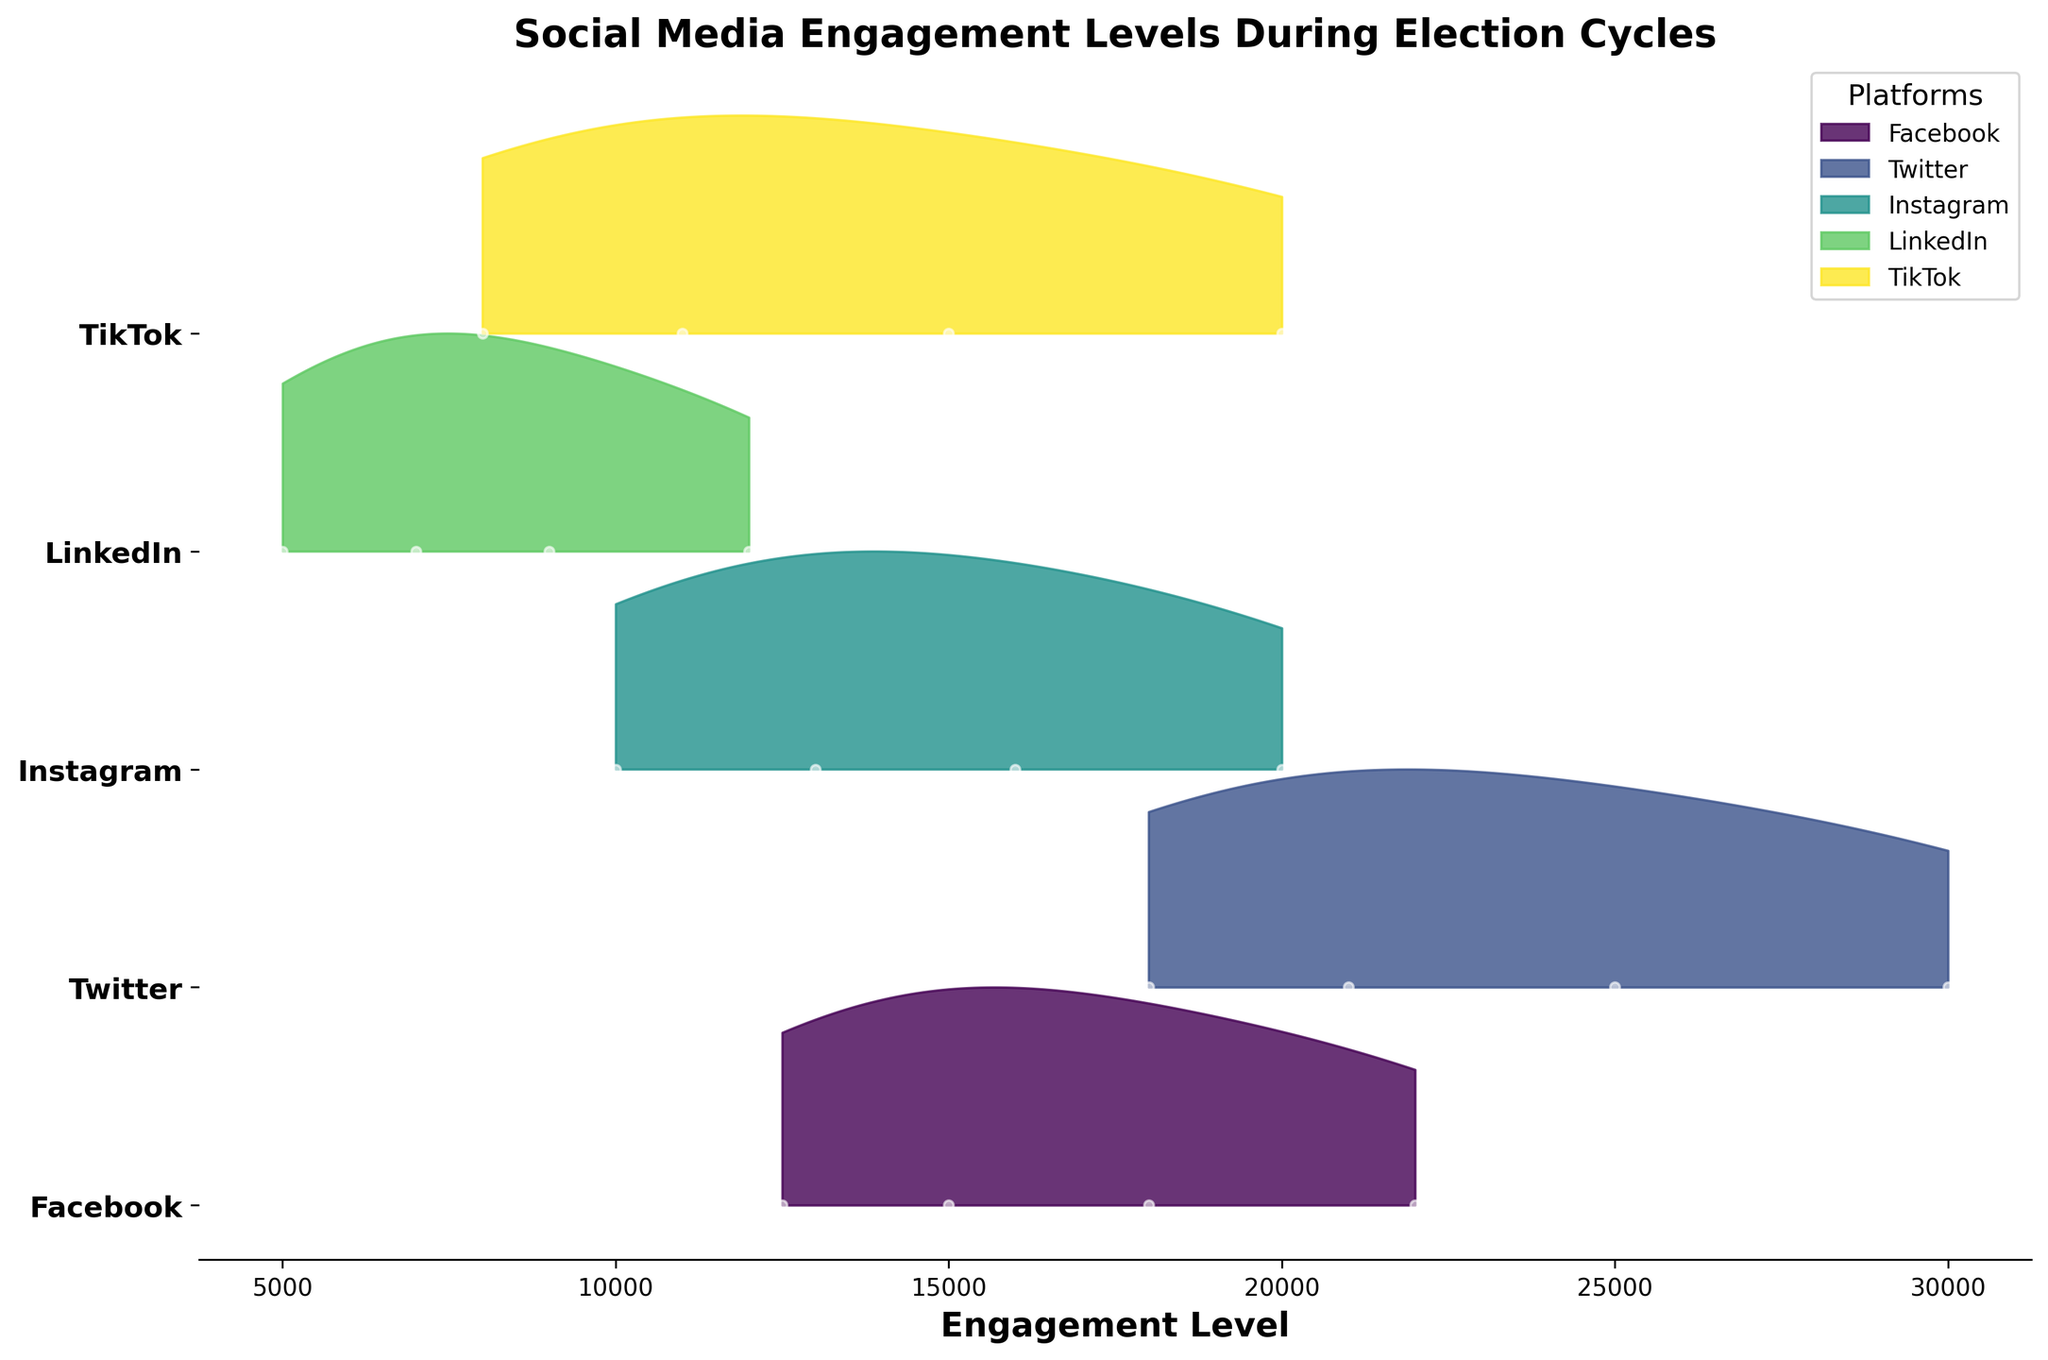What is the title of the plot? The title is located at the top of the plot and is usually in larger and bold font to grab attention. It summarizes the main subject of the plot.
Answer: Social Media Engagement Levels During Election Cycles How many social media platforms are represented in the plot? Count the different platform names listed on the y-axis of the plot.
Answer: 5 What does each color represent in the plot? Different colors in the plot are used to distinguish between the various social media platforms. This can usually be seen in the legend.
Answer: Different social media platforms Which social media platform has the highest engagement level in week 4? Look at the engagement levels for each platform in week 4 and identify the highest value.
Answer: Twitter Which platform shows the smallest increase in engagement from week 1 to week 4? Calculate the increase in engagement from week 1 to week 4 for each platform and find the smallest value. LinkedIn: 12000 - 5000 = 7000; Twitter: 30000 - 18000 = 12000; Facebook: 22000 - 12500 = 9500; Instagram: 20000 - 10000 = 10000; TikTok: 20000 - 8000 = 12000. LinkedIn has the smallest increase.
Answer: LinkedIn What is the difference in engagement levels between the highest and lowest engaged platforms in week 2? Identify the engagement levels for all platforms in week 2. The highest is for Twitter (21000) and the lowest is for LinkedIn (7000). Calculate the difference 21000 - 7000 = 14000.
Answer: 14000 Which platform shows the most consistent engagement levels across the weeks? Observe the range and spread of engagement levels across the weeks for each platform. LinkedIn's engagement levels exhibit a consistent and gradual increase from 5000 to 12000 without large fluctuations.
Answer: LinkedIn What is the general trend of engagement levels across all platforms during the election cycle? Look for overall patterns of increase, decrease, or steadiness in the engagement levels over the weeks. Most platforms show an increasing trend in engagement levels as the weeks progress.
Answer: Increasing trend How does the engagement level of Instagram in week 3 compare to the engagement level of Facebook in week 2? Check the engagement levels of Instagram in week 3 (16000) and Facebook in week 2 (15000). Compare these values to see which is higher.
Answer: Instagram's is higher 